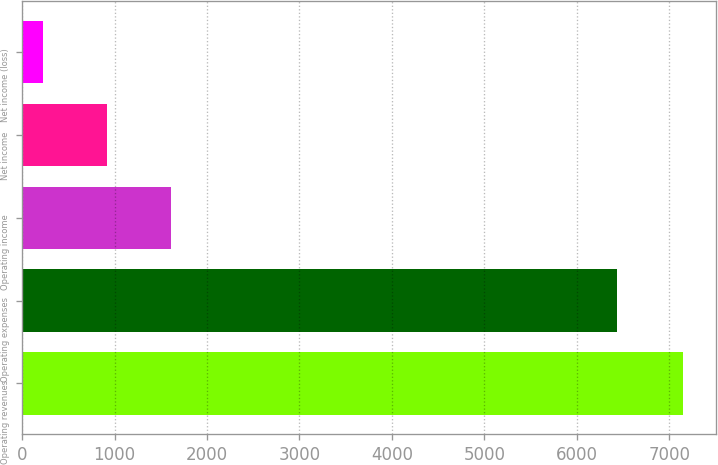<chart> <loc_0><loc_0><loc_500><loc_500><bar_chart><fcel>Operating revenues<fcel>Operating expenses<fcel>Operating income<fcel>Net income<fcel>Net income (loss)<nl><fcel>7153<fcel>6435<fcel>1613<fcel>920.5<fcel>228<nl></chart> 